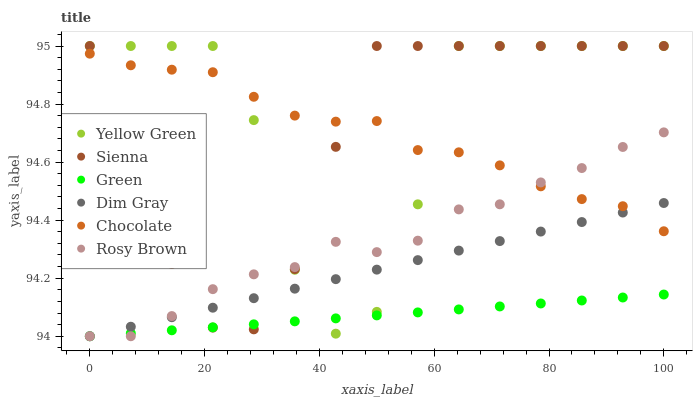Does Green have the minimum area under the curve?
Answer yes or no. Yes. Does Yellow Green have the maximum area under the curve?
Answer yes or no. Yes. Does Rosy Brown have the minimum area under the curve?
Answer yes or no. No. Does Rosy Brown have the maximum area under the curve?
Answer yes or no. No. Is Green the smoothest?
Answer yes or no. Yes. Is Yellow Green the roughest?
Answer yes or no. Yes. Is Rosy Brown the smoothest?
Answer yes or no. No. Is Rosy Brown the roughest?
Answer yes or no. No. Does Dim Gray have the lowest value?
Answer yes or no. Yes. Does Yellow Green have the lowest value?
Answer yes or no. No. Does Sienna have the highest value?
Answer yes or no. Yes. Does Rosy Brown have the highest value?
Answer yes or no. No. Is Green less than Chocolate?
Answer yes or no. Yes. Is Chocolate greater than Green?
Answer yes or no. Yes. Does Dim Gray intersect Sienna?
Answer yes or no. Yes. Is Dim Gray less than Sienna?
Answer yes or no. No. Is Dim Gray greater than Sienna?
Answer yes or no. No. Does Green intersect Chocolate?
Answer yes or no. No. 